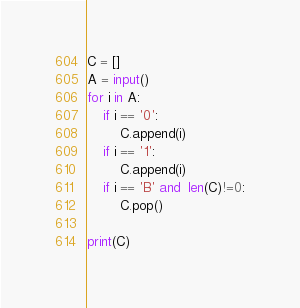Convert code to text. <code><loc_0><loc_0><loc_500><loc_500><_Python_>C = []
A = input()
for i in A:
    if i == '0':
        C.append(i)
    if i == '1':
        C.append(i)
    if i == 'B' and  len(C)!=0:
        C.pop()

print(C)</code> 